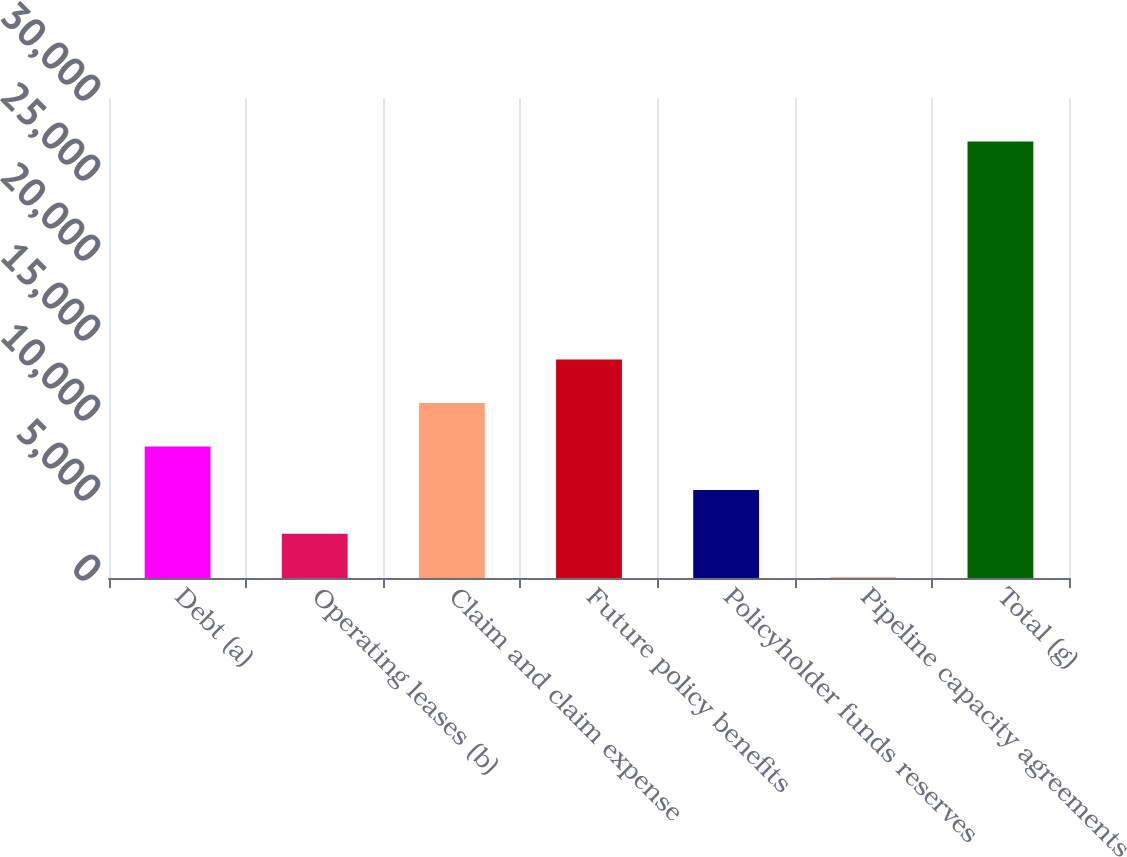Convert chart. <chart><loc_0><loc_0><loc_500><loc_500><bar_chart><fcel>Debt (a)<fcel>Operating leases (b)<fcel>Claim and claim expense<fcel>Future policy benefits<fcel>Policyholder funds reserves<fcel>Pipeline capacity agreements<fcel>Total (g)<nl><fcel>8216.3<fcel>2770.1<fcel>10939.4<fcel>13662.5<fcel>5493.2<fcel>47<fcel>27278<nl></chart> 